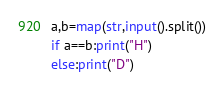Convert code to text. <code><loc_0><loc_0><loc_500><loc_500><_Python_>a,b=map(str,input().split())
if a==b:print("H")
else:print("D")</code> 